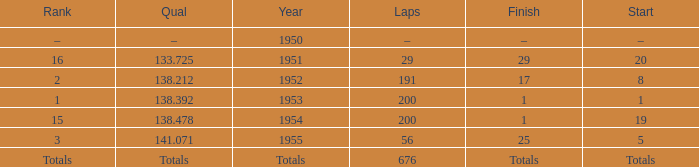Can you give me this table as a dict? {'header': ['Rank', 'Qual', 'Year', 'Laps', 'Finish', 'Start'], 'rows': [['–', '–', '1950', '–', '–', '–'], ['16', '133.725', '1951', '29', '29', '20'], ['2', '138.212', '1952', '191', '17', '8'], ['1', '138.392', '1953', '200', '1', '1'], ['15', '138.478', '1954', '200', '1', '19'], ['3', '141.071', '1955', '56', '25', '5'], ['Totals', 'Totals', 'Totals', '676', 'Totals', 'Totals']]} How many laps does the one ranked 16 have? 29.0. 